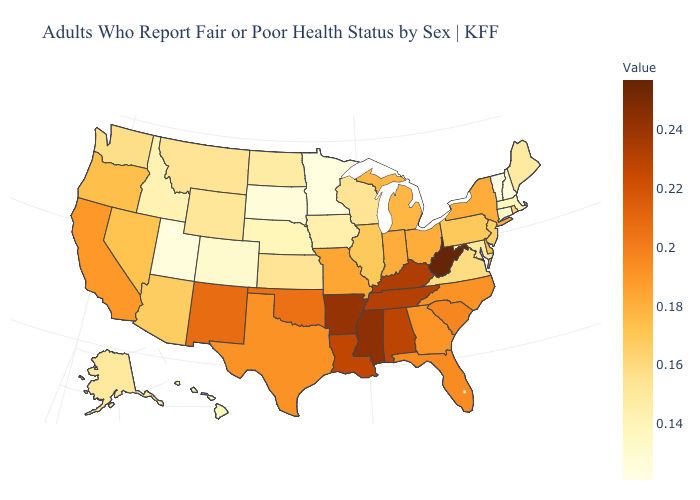Does California have the highest value in the USA?
Give a very brief answer. No. Does New York have a higher value than Arkansas?
Be succinct. No. Does Arizona have the lowest value in the West?
Be succinct. No. Does the map have missing data?
Be succinct. No. Does Vermont have the lowest value in the USA?
Answer briefly. Yes. Does Massachusetts have a higher value than Vermont?
Short answer required. Yes. Among the states that border Georgia , which have the highest value?
Quick response, please. Tennessee. 